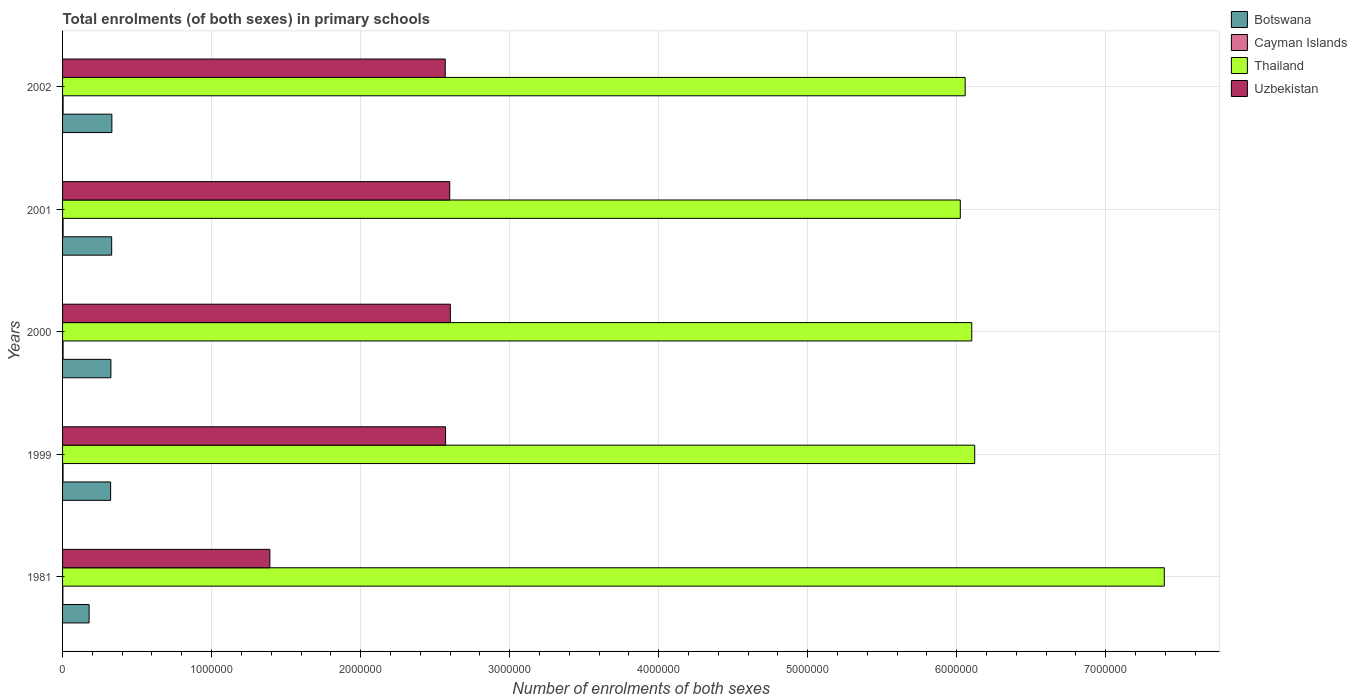How many different coloured bars are there?
Give a very brief answer. 4. How many groups of bars are there?
Make the answer very short. 5. Are the number of bars per tick equal to the number of legend labels?
Your answer should be very brief. Yes. Are the number of bars on each tick of the Y-axis equal?
Keep it short and to the point. Yes. How many bars are there on the 5th tick from the bottom?
Make the answer very short. 4. What is the number of enrolments in primary schools in Uzbekistan in 1999?
Your answer should be very brief. 2.57e+06. Across all years, what is the maximum number of enrolments in primary schools in Cayman Islands?
Your answer should be compact. 3579. Across all years, what is the minimum number of enrolments in primary schools in Uzbekistan?
Make the answer very short. 1.39e+06. What is the total number of enrolments in primary schools in Thailand in the graph?
Provide a short and direct response. 3.17e+07. What is the difference between the number of enrolments in primary schools in Thailand in 2000 and that in 2002?
Your answer should be very brief. 4.42e+04. What is the difference between the number of enrolments in primary schools in Cayman Islands in 1981 and the number of enrolments in primary schools in Thailand in 2002?
Make the answer very short. -6.05e+06. What is the average number of enrolments in primary schools in Uzbekistan per year?
Ensure brevity in your answer.  2.35e+06. In the year 2002, what is the difference between the number of enrolments in primary schools in Thailand and number of enrolments in primary schools in Botswana?
Ensure brevity in your answer.  5.73e+06. What is the ratio of the number of enrolments in primary schools in Uzbekistan in 1999 to that in 2002?
Give a very brief answer. 1. Is the number of enrolments in primary schools in Cayman Islands in 2001 less than that in 2002?
Keep it short and to the point. Yes. What is the difference between the highest and the second highest number of enrolments in primary schools in Thailand?
Provide a succinct answer. 1.27e+06. What is the difference between the highest and the lowest number of enrolments in primary schools in Cayman Islands?
Give a very brief answer. 1456. What does the 2nd bar from the top in 1981 represents?
Your answer should be very brief. Thailand. What does the 3rd bar from the bottom in 2000 represents?
Offer a very short reply. Thailand. How many bars are there?
Your answer should be very brief. 20. What is the difference between two consecutive major ticks on the X-axis?
Provide a succinct answer. 1.00e+06. Does the graph contain any zero values?
Make the answer very short. No. Does the graph contain grids?
Ensure brevity in your answer.  Yes. How many legend labels are there?
Offer a very short reply. 4. What is the title of the graph?
Provide a short and direct response. Total enrolments (of both sexes) in primary schools. What is the label or title of the X-axis?
Your answer should be very brief. Number of enrolments of both sexes. What is the Number of enrolments of both sexes of Botswana in 1981?
Your answer should be compact. 1.78e+05. What is the Number of enrolments of both sexes in Cayman Islands in 1981?
Provide a succinct answer. 2123. What is the Number of enrolments of both sexes in Thailand in 1981?
Make the answer very short. 7.39e+06. What is the Number of enrolments of both sexes of Uzbekistan in 1981?
Your response must be concise. 1.39e+06. What is the Number of enrolments of both sexes in Botswana in 1999?
Provide a succinct answer. 3.22e+05. What is the Number of enrolments of both sexes of Cayman Islands in 1999?
Offer a very short reply. 3231. What is the Number of enrolments of both sexes in Thailand in 1999?
Offer a terse response. 6.12e+06. What is the Number of enrolments of both sexes of Uzbekistan in 1999?
Provide a short and direct response. 2.57e+06. What is the Number of enrolments of both sexes of Botswana in 2000?
Your response must be concise. 3.24e+05. What is the Number of enrolments of both sexes of Cayman Islands in 2000?
Your answer should be very brief. 3435. What is the Number of enrolments of both sexes of Thailand in 2000?
Make the answer very short. 6.10e+06. What is the Number of enrolments of both sexes of Uzbekistan in 2000?
Give a very brief answer. 2.60e+06. What is the Number of enrolments of both sexes of Botswana in 2001?
Your answer should be compact. 3.29e+05. What is the Number of enrolments of both sexes of Cayman Islands in 2001?
Provide a short and direct response. 3549. What is the Number of enrolments of both sexes in Thailand in 2001?
Provide a short and direct response. 6.02e+06. What is the Number of enrolments of both sexes of Uzbekistan in 2001?
Offer a terse response. 2.60e+06. What is the Number of enrolments of both sexes of Botswana in 2002?
Provide a succinct answer. 3.31e+05. What is the Number of enrolments of both sexes of Cayman Islands in 2002?
Offer a very short reply. 3579. What is the Number of enrolments of both sexes in Thailand in 2002?
Ensure brevity in your answer.  6.06e+06. What is the Number of enrolments of both sexes in Uzbekistan in 2002?
Provide a succinct answer. 2.57e+06. Across all years, what is the maximum Number of enrolments of both sexes of Botswana?
Provide a short and direct response. 3.31e+05. Across all years, what is the maximum Number of enrolments of both sexes of Cayman Islands?
Keep it short and to the point. 3579. Across all years, what is the maximum Number of enrolments of both sexes in Thailand?
Your answer should be very brief. 7.39e+06. Across all years, what is the maximum Number of enrolments of both sexes in Uzbekistan?
Your answer should be compact. 2.60e+06. Across all years, what is the minimum Number of enrolments of both sexes in Botswana?
Keep it short and to the point. 1.78e+05. Across all years, what is the minimum Number of enrolments of both sexes in Cayman Islands?
Make the answer very short. 2123. Across all years, what is the minimum Number of enrolments of both sexes of Thailand?
Your response must be concise. 6.02e+06. Across all years, what is the minimum Number of enrolments of both sexes of Uzbekistan?
Your answer should be very brief. 1.39e+06. What is the total Number of enrolments of both sexes of Botswana in the graph?
Offer a very short reply. 1.49e+06. What is the total Number of enrolments of both sexes of Cayman Islands in the graph?
Give a very brief answer. 1.59e+04. What is the total Number of enrolments of both sexes in Thailand in the graph?
Offer a terse response. 3.17e+07. What is the total Number of enrolments of both sexes of Uzbekistan in the graph?
Ensure brevity in your answer.  1.17e+07. What is the difference between the Number of enrolments of both sexes in Botswana in 1981 and that in 1999?
Your response must be concise. -1.44e+05. What is the difference between the Number of enrolments of both sexes in Cayman Islands in 1981 and that in 1999?
Offer a very short reply. -1108. What is the difference between the Number of enrolments of both sexes of Thailand in 1981 and that in 1999?
Make the answer very short. 1.27e+06. What is the difference between the Number of enrolments of both sexes of Uzbekistan in 1981 and that in 1999?
Provide a succinct answer. -1.18e+06. What is the difference between the Number of enrolments of both sexes in Botswana in 1981 and that in 2000?
Your answer should be very brief. -1.46e+05. What is the difference between the Number of enrolments of both sexes of Cayman Islands in 1981 and that in 2000?
Provide a succinct answer. -1312. What is the difference between the Number of enrolments of both sexes in Thailand in 1981 and that in 2000?
Offer a terse response. 1.29e+06. What is the difference between the Number of enrolments of both sexes of Uzbekistan in 1981 and that in 2000?
Provide a succinct answer. -1.21e+06. What is the difference between the Number of enrolments of both sexes in Botswana in 1981 and that in 2001?
Your answer should be very brief. -1.51e+05. What is the difference between the Number of enrolments of both sexes of Cayman Islands in 1981 and that in 2001?
Offer a very short reply. -1426. What is the difference between the Number of enrolments of both sexes in Thailand in 1981 and that in 2001?
Offer a terse response. 1.37e+06. What is the difference between the Number of enrolments of both sexes in Uzbekistan in 1981 and that in 2001?
Offer a terse response. -1.21e+06. What is the difference between the Number of enrolments of both sexes in Botswana in 1981 and that in 2002?
Make the answer very short. -1.53e+05. What is the difference between the Number of enrolments of both sexes in Cayman Islands in 1981 and that in 2002?
Your answer should be very brief. -1456. What is the difference between the Number of enrolments of both sexes of Thailand in 1981 and that in 2002?
Give a very brief answer. 1.34e+06. What is the difference between the Number of enrolments of both sexes in Uzbekistan in 1981 and that in 2002?
Ensure brevity in your answer.  -1.18e+06. What is the difference between the Number of enrolments of both sexes of Botswana in 1999 and that in 2000?
Offer a very short reply. -1808. What is the difference between the Number of enrolments of both sexes in Cayman Islands in 1999 and that in 2000?
Your response must be concise. -204. What is the difference between the Number of enrolments of both sexes of Thailand in 1999 and that in 2000?
Keep it short and to the point. 1.98e+04. What is the difference between the Number of enrolments of both sexes of Uzbekistan in 1999 and that in 2000?
Keep it short and to the point. -3.21e+04. What is the difference between the Number of enrolments of both sexes of Botswana in 1999 and that in 2001?
Make the answer very short. -6976. What is the difference between the Number of enrolments of both sexes in Cayman Islands in 1999 and that in 2001?
Give a very brief answer. -318. What is the difference between the Number of enrolments of both sexes of Thailand in 1999 and that in 2001?
Provide a succinct answer. 9.67e+04. What is the difference between the Number of enrolments of both sexes in Uzbekistan in 1999 and that in 2001?
Keep it short and to the point. -2.80e+04. What is the difference between the Number of enrolments of both sexes in Botswana in 1999 and that in 2002?
Ensure brevity in your answer.  -8360. What is the difference between the Number of enrolments of both sexes of Cayman Islands in 1999 and that in 2002?
Ensure brevity in your answer.  -348. What is the difference between the Number of enrolments of both sexes of Thailand in 1999 and that in 2002?
Provide a short and direct response. 6.40e+04. What is the difference between the Number of enrolments of both sexes of Uzbekistan in 1999 and that in 2002?
Your answer should be compact. 2167. What is the difference between the Number of enrolments of both sexes of Botswana in 2000 and that in 2001?
Your answer should be very brief. -5168. What is the difference between the Number of enrolments of both sexes of Cayman Islands in 2000 and that in 2001?
Keep it short and to the point. -114. What is the difference between the Number of enrolments of both sexes in Thailand in 2000 and that in 2001?
Offer a terse response. 7.69e+04. What is the difference between the Number of enrolments of both sexes in Uzbekistan in 2000 and that in 2001?
Ensure brevity in your answer.  4067. What is the difference between the Number of enrolments of both sexes in Botswana in 2000 and that in 2002?
Ensure brevity in your answer.  -6552. What is the difference between the Number of enrolments of both sexes of Cayman Islands in 2000 and that in 2002?
Your answer should be very brief. -144. What is the difference between the Number of enrolments of both sexes in Thailand in 2000 and that in 2002?
Provide a succinct answer. 4.42e+04. What is the difference between the Number of enrolments of both sexes in Uzbekistan in 2000 and that in 2002?
Give a very brief answer. 3.43e+04. What is the difference between the Number of enrolments of both sexes in Botswana in 2001 and that in 2002?
Give a very brief answer. -1384. What is the difference between the Number of enrolments of both sexes of Cayman Islands in 2001 and that in 2002?
Your answer should be very brief. -30. What is the difference between the Number of enrolments of both sexes in Thailand in 2001 and that in 2002?
Your answer should be very brief. -3.27e+04. What is the difference between the Number of enrolments of both sexes in Uzbekistan in 2001 and that in 2002?
Your response must be concise. 3.02e+04. What is the difference between the Number of enrolments of both sexes of Botswana in 1981 and the Number of enrolments of both sexes of Cayman Islands in 1999?
Provide a short and direct response. 1.75e+05. What is the difference between the Number of enrolments of both sexes of Botswana in 1981 and the Number of enrolments of both sexes of Thailand in 1999?
Give a very brief answer. -5.94e+06. What is the difference between the Number of enrolments of both sexes of Botswana in 1981 and the Number of enrolments of both sexes of Uzbekistan in 1999?
Ensure brevity in your answer.  -2.39e+06. What is the difference between the Number of enrolments of both sexes of Cayman Islands in 1981 and the Number of enrolments of both sexes of Thailand in 1999?
Offer a terse response. -6.12e+06. What is the difference between the Number of enrolments of both sexes in Cayman Islands in 1981 and the Number of enrolments of both sexes in Uzbekistan in 1999?
Offer a very short reply. -2.57e+06. What is the difference between the Number of enrolments of both sexes in Thailand in 1981 and the Number of enrolments of both sexes in Uzbekistan in 1999?
Make the answer very short. 4.82e+06. What is the difference between the Number of enrolments of both sexes of Botswana in 1981 and the Number of enrolments of both sexes of Cayman Islands in 2000?
Keep it short and to the point. 1.75e+05. What is the difference between the Number of enrolments of both sexes in Botswana in 1981 and the Number of enrolments of both sexes in Thailand in 2000?
Your response must be concise. -5.92e+06. What is the difference between the Number of enrolments of both sexes in Botswana in 1981 and the Number of enrolments of both sexes in Uzbekistan in 2000?
Provide a short and direct response. -2.42e+06. What is the difference between the Number of enrolments of both sexes in Cayman Islands in 1981 and the Number of enrolments of both sexes in Thailand in 2000?
Provide a succinct answer. -6.10e+06. What is the difference between the Number of enrolments of both sexes in Cayman Islands in 1981 and the Number of enrolments of both sexes in Uzbekistan in 2000?
Keep it short and to the point. -2.60e+06. What is the difference between the Number of enrolments of both sexes of Thailand in 1981 and the Number of enrolments of both sexes of Uzbekistan in 2000?
Ensure brevity in your answer.  4.79e+06. What is the difference between the Number of enrolments of both sexes in Botswana in 1981 and the Number of enrolments of both sexes in Cayman Islands in 2001?
Make the answer very short. 1.75e+05. What is the difference between the Number of enrolments of both sexes of Botswana in 1981 and the Number of enrolments of both sexes of Thailand in 2001?
Provide a succinct answer. -5.85e+06. What is the difference between the Number of enrolments of both sexes in Botswana in 1981 and the Number of enrolments of both sexes in Uzbekistan in 2001?
Your answer should be very brief. -2.42e+06. What is the difference between the Number of enrolments of both sexes in Cayman Islands in 1981 and the Number of enrolments of both sexes in Thailand in 2001?
Your response must be concise. -6.02e+06. What is the difference between the Number of enrolments of both sexes in Cayman Islands in 1981 and the Number of enrolments of both sexes in Uzbekistan in 2001?
Make the answer very short. -2.60e+06. What is the difference between the Number of enrolments of both sexes in Thailand in 1981 and the Number of enrolments of both sexes in Uzbekistan in 2001?
Keep it short and to the point. 4.79e+06. What is the difference between the Number of enrolments of both sexes of Botswana in 1981 and the Number of enrolments of both sexes of Cayman Islands in 2002?
Ensure brevity in your answer.  1.75e+05. What is the difference between the Number of enrolments of both sexes in Botswana in 1981 and the Number of enrolments of both sexes in Thailand in 2002?
Make the answer very short. -5.88e+06. What is the difference between the Number of enrolments of both sexes of Botswana in 1981 and the Number of enrolments of both sexes of Uzbekistan in 2002?
Ensure brevity in your answer.  -2.39e+06. What is the difference between the Number of enrolments of both sexes of Cayman Islands in 1981 and the Number of enrolments of both sexes of Thailand in 2002?
Provide a succinct answer. -6.05e+06. What is the difference between the Number of enrolments of both sexes in Cayman Islands in 1981 and the Number of enrolments of both sexes in Uzbekistan in 2002?
Your answer should be very brief. -2.57e+06. What is the difference between the Number of enrolments of both sexes in Thailand in 1981 and the Number of enrolments of both sexes in Uzbekistan in 2002?
Provide a short and direct response. 4.82e+06. What is the difference between the Number of enrolments of both sexes of Botswana in 1999 and the Number of enrolments of both sexes of Cayman Islands in 2000?
Provide a short and direct response. 3.19e+05. What is the difference between the Number of enrolments of both sexes in Botswana in 1999 and the Number of enrolments of both sexes in Thailand in 2000?
Provide a short and direct response. -5.78e+06. What is the difference between the Number of enrolments of both sexes of Botswana in 1999 and the Number of enrolments of both sexes of Uzbekistan in 2000?
Provide a short and direct response. -2.28e+06. What is the difference between the Number of enrolments of both sexes in Cayman Islands in 1999 and the Number of enrolments of both sexes in Thailand in 2000?
Make the answer very short. -6.10e+06. What is the difference between the Number of enrolments of both sexes of Cayman Islands in 1999 and the Number of enrolments of both sexes of Uzbekistan in 2000?
Give a very brief answer. -2.60e+06. What is the difference between the Number of enrolments of both sexes in Thailand in 1999 and the Number of enrolments of both sexes in Uzbekistan in 2000?
Your response must be concise. 3.52e+06. What is the difference between the Number of enrolments of both sexes in Botswana in 1999 and the Number of enrolments of both sexes in Cayman Islands in 2001?
Your response must be concise. 3.19e+05. What is the difference between the Number of enrolments of both sexes in Botswana in 1999 and the Number of enrolments of both sexes in Thailand in 2001?
Offer a very short reply. -5.70e+06. What is the difference between the Number of enrolments of both sexes in Botswana in 1999 and the Number of enrolments of both sexes in Uzbekistan in 2001?
Give a very brief answer. -2.28e+06. What is the difference between the Number of enrolments of both sexes in Cayman Islands in 1999 and the Number of enrolments of both sexes in Thailand in 2001?
Make the answer very short. -6.02e+06. What is the difference between the Number of enrolments of both sexes in Cayman Islands in 1999 and the Number of enrolments of both sexes in Uzbekistan in 2001?
Give a very brief answer. -2.59e+06. What is the difference between the Number of enrolments of both sexes in Thailand in 1999 and the Number of enrolments of both sexes in Uzbekistan in 2001?
Give a very brief answer. 3.52e+06. What is the difference between the Number of enrolments of both sexes of Botswana in 1999 and the Number of enrolments of both sexes of Cayman Islands in 2002?
Provide a short and direct response. 3.19e+05. What is the difference between the Number of enrolments of both sexes of Botswana in 1999 and the Number of enrolments of both sexes of Thailand in 2002?
Keep it short and to the point. -5.73e+06. What is the difference between the Number of enrolments of both sexes of Botswana in 1999 and the Number of enrolments of both sexes of Uzbekistan in 2002?
Offer a terse response. -2.25e+06. What is the difference between the Number of enrolments of both sexes in Cayman Islands in 1999 and the Number of enrolments of both sexes in Thailand in 2002?
Provide a short and direct response. -6.05e+06. What is the difference between the Number of enrolments of both sexes in Cayman Islands in 1999 and the Number of enrolments of both sexes in Uzbekistan in 2002?
Offer a very short reply. -2.56e+06. What is the difference between the Number of enrolments of both sexes of Thailand in 1999 and the Number of enrolments of both sexes of Uzbekistan in 2002?
Provide a short and direct response. 3.55e+06. What is the difference between the Number of enrolments of both sexes in Botswana in 2000 and the Number of enrolments of both sexes in Cayman Islands in 2001?
Your answer should be very brief. 3.21e+05. What is the difference between the Number of enrolments of both sexes of Botswana in 2000 and the Number of enrolments of both sexes of Thailand in 2001?
Your answer should be compact. -5.70e+06. What is the difference between the Number of enrolments of both sexes in Botswana in 2000 and the Number of enrolments of both sexes in Uzbekistan in 2001?
Provide a short and direct response. -2.27e+06. What is the difference between the Number of enrolments of both sexes in Cayman Islands in 2000 and the Number of enrolments of both sexes in Thailand in 2001?
Make the answer very short. -6.02e+06. What is the difference between the Number of enrolments of both sexes in Cayman Islands in 2000 and the Number of enrolments of both sexes in Uzbekistan in 2001?
Keep it short and to the point. -2.59e+06. What is the difference between the Number of enrolments of both sexes in Thailand in 2000 and the Number of enrolments of both sexes in Uzbekistan in 2001?
Your answer should be very brief. 3.50e+06. What is the difference between the Number of enrolments of both sexes of Botswana in 2000 and the Number of enrolments of both sexes of Cayman Islands in 2002?
Your answer should be compact. 3.21e+05. What is the difference between the Number of enrolments of both sexes in Botswana in 2000 and the Number of enrolments of both sexes in Thailand in 2002?
Your answer should be compact. -5.73e+06. What is the difference between the Number of enrolments of both sexes in Botswana in 2000 and the Number of enrolments of both sexes in Uzbekistan in 2002?
Offer a very short reply. -2.24e+06. What is the difference between the Number of enrolments of both sexes of Cayman Islands in 2000 and the Number of enrolments of both sexes of Thailand in 2002?
Your response must be concise. -6.05e+06. What is the difference between the Number of enrolments of both sexes of Cayman Islands in 2000 and the Number of enrolments of both sexes of Uzbekistan in 2002?
Provide a succinct answer. -2.56e+06. What is the difference between the Number of enrolments of both sexes in Thailand in 2000 and the Number of enrolments of both sexes in Uzbekistan in 2002?
Make the answer very short. 3.53e+06. What is the difference between the Number of enrolments of both sexes in Botswana in 2001 and the Number of enrolments of both sexes in Cayman Islands in 2002?
Ensure brevity in your answer.  3.26e+05. What is the difference between the Number of enrolments of both sexes in Botswana in 2001 and the Number of enrolments of both sexes in Thailand in 2002?
Your answer should be very brief. -5.73e+06. What is the difference between the Number of enrolments of both sexes of Botswana in 2001 and the Number of enrolments of both sexes of Uzbekistan in 2002?
Ensure brevity in your answer.  -2.24e+06. What is the difference between the Number of enrolments of both sexes in Cayman Islands in 2001 and the Number of enrolments of both sexes in Thailand in 2002?
Give a very brief answer. -6.05e+06. What is the difference between the Number of enrolments of both sexes in Cayman Islands in 2001 and the Number of enrolments of both sexes in Uzbekistan in 2002?
Offer a terse response. -2.56e+06. What is the difference between the Number of enrolments of both sexes in Thailand in 2001 and the Number of enrolments of both sexes in Uzbekistan in 2002?
Make the answer very short. 3.46e+06. What is the average Number of enrolments of both sexes of Botswana per year?
Your answer should be very brief. 2.97e+05. What is the average Number of enrolments of both sexes in Cayman Islands per year?
Keep it short and to the point. 3183.4. What is the average Number of enrolments of both sexes of Thailand per year?
Keep it short and to the point. 6.34e+06. What is the average Number of enrolments of both sexes in Uzbekistan per year?
Keep it short and to the point. 2.35e+06. In the year 1981, what is the difference between the Number of enrolments of both sexes of Botswana and Number of enrolments of both sexes of Cayman Islands?
Provide a short and direct response. 1.76e+05. In the year 1981, what is the difference between the Number of enrolments of both sexes of Botswana and Number of enrolments of both sexes of Thailand?
Offer a very short reply. -7.21e+06. In the year 1981, what is the difference between the Number of enrolments of both sexes in Botswana and Number of enrolments of both sexes in Uzbekistan?
Your answer should be compact. -1.21e+06. In the year 1981, what is the difference between the Number of enrolments of both sexes in Cayman Islands and Number of enrolments of both sexes in Thailand?
Offer a very short reply. -7.39e+06. In the year 1981, what is the difference between the Number of enrolments of both sexes in Cayman Islands and Number of enrolments of both sexes in Uzbekistan?
Your answer should be compact. -1.39e+06. In the year 1981, what is the difference between the Number of enrolments of both sexes of Thailand and Number of enrolments of both sexes of Uzbekistan?
Your answer should be compact. 6.00e+06. In the year 1999, what is the difference between the Number of enrolments of both sexes of Botswana and Number of enrolments of both sexes of Cayman Islands?
Offer a terse response. 3.19e+05. In the year 1999, what is the difference between the Number of enrolments of both sexes in Botswana and Number of enrolments of both sexes in Thailand?
Provide a succinct answer. -5.80e+06. In the year 1999, what is the difference between the Number of enrolments of both sexes of Botswana and Number of enrolments of both sexes of Uzbekistan?
Ensure brevity in your answer.  -2.25e+06. In the year 1999, what is the difference between the Number of enrolments of both sexes in Cayman Islands and Number of enrolments of both sexes in Thailand?
Give a very brief answer. -6.12e+06. In the year 1999, what is the difference between the Number of enrolments of both sexes of Cayman Islands and Number of enrolments of both sexes of Uzbekistan?
Offer a very short reply. -2.57e+06. In the year 1999, what is the difference between the Number of enrolments of both sexes of Thailand and Number of enrolments of both sexes of Uzbekistan?
Provide a short and direct response. 3.55e+06. In the year 2000, what is the difference between the Number of enrolments of both sexes in Botswana and Number of enrolments of both sexes in Cayman Islands?
Provide a short and direct response. 3.21e+05. In the year 2000, what is the difference between the Number of enrolments of both sexes in Botswana and Number of enrolments of both sexes in Thailand?
Your answer should be compact. -5.78e+06. In the year 2000, what is the difference between the Number of enrolments of both sexes in Botswana and Number of enrolments of both sexes in Uzbekistan?
Make the answer very short. -2.28e+06. In the year 2000, what is the difference between the Number of enrolments of both sexes in Cayman Islands and Number of enrolments of both sexes in Thailand?
Offer a terse response. -6.10e+06. In the year 2000, what is the difference between the Number of enrolments of both sexes of Cayman Islands and Number of enrolments of both sexes of Uzbekistan?
Give a very brief answer. -2.60e+06. In the year 2000, what is the difference between the Number of enrolments of both sexes of Thailand and Number of enrolments of both sexes of Uzbekistan?
Make the answer very short. 3.50e+06. In the year 2001, what is the difference between the Number of enrolments of both sexes in Botswana and Number of enrolments of both sexes in Cayman Islands?
Your response must be concise. 3.26e+05. In the year 2001, what is the difference between the Number of enrolments of both sexes in Botswana and Number of enrolments of both sexes in Thailand?
Your answer should be compact. -5.69e+06. In the year 2001, what is the difference between the Number of enrolments of both sexes of Botswana and Number of enrolments of both sexes of Uzbekistan?
Give a very brief answer. -2.27e+06. In the year 2001, what is the difference between the Number of enrolments of both sexes in Cayman Islands and Number of enrolments of both sexes in Thailand?
Provide a short and direct response. -6.02e+06. In the year 2001, what is the difference between the Number of enrolments of both sexes in Cayman Islands and Number of enrolments of both sexes in Uzbekistan?
Your response must be concise. -2.59e+06. In the year 2001, what is the difference between the Number of enrolments of both sexes in Thailand and Number of enrolments of both sexes in Uzbekistan?
Ensure brevity in your answer.  3.43e+06. In the year 2002, what is the difference between the Number of enrolments of both sexes of Botswana and Number of enrolments of both sexes of Cayman Islands?
Offer a very short reply. 3.27e+05. In the year 2002, what is the difference between the Number of enrolments of both sexes of Botswana and Number of enrolments of both sexes of Thailand?
Ensure brevity in your answer.  -5.73e+06. In the year 2002, what is the difference between the Number of enrolments of both sexes of Botswana and Number of enrolments of both sexes of Uzbekistan?
Ensure brevity in your answer.  -2.24e+06. In the year 2002, what is the difference between the Number of enrolments of both sexes in Cayman Islands and Number of enrolments of both sexes in Thailand?
Offer a terse response. -6.05e+06. In the year 2002, what is the difference between the Number of enrolments of both sexes in Cayman Islands and Number of enrolments of both sexes in Uzbekistan?
Your response must be concise. -2.56e+06. In the year 2002, what is the difference between the Number of enrolments of both sexes of Thailand and Number of enrolments of both sexes of Uzbekistan?
Give a very brief answer. 3.49e+06. What is the ratio of the Number of enrolments of both sexes in Botswana in 1981 to that in 1999?
Give a very brief answer. 0.55. What is the ratio of the Number of enrolments of both sexes in Cayman Islands in 1981 to that in 1999?
Your answer should be very brief. 0.66. What is the ratio of the Number of enrolments of both sexes of Thailand in 1981 to that in 1999?
Provide a short and direct response. 1.21. What is the ratio of the Number of enrolments of both sexes in Uzbekistan in 1981 to that in 1999?
Provide a short and direct response. 0.54. What is the ratio of the Number of enrolments of both sexes of Botswana in 1981 to that in 2000?
Provide a succinct answer. 0.55. What is the ratio of the Number of enrolments of both sexes of Cayman Islands in 1981 to that in 2000?
Offer a very short reply. 0.62. What is the ratio of the Number of enrolments of both sexes of Thailand in 1981 to that in 2000?
Offer a very short reply. 1.21. What is the ratio of the Number of enrolments of both sexes in Uzbekistan in 1981 to that in 2000?
Your answer should be very brief. 0.53. What is the ratio of the Number of enrolments of both sexes in Botswana in 1981 to that in 2001?
Make the answer very short. 0.54. What is the ratio of the Number of enrolments of both sexes in Cayman Islands in 1981 to that in 2001?
Your answer should be very brief. 0.6. What is the ratio of the Number of enrolments of both sexes in Thailand in 1981 to that in 2001?
Your answer should be compact. 1.23. What is the ratio of the Number of enrolments of both sexes of Uzbekistan in 1981 to that in 2001?
Offer a very short reply. 0.54. What is the ratio of the Number of enrolments of both sexes of Botswana in 1981 to that in 2002?
Provide a succinct answer. 0.54. What is the ratio of the Number of enrolments of both sexes in Cayman Islands in 1981 to that in 2002?
Your response must be concise. 0.59. What is the ratio of the Number of enrolments of both sexes of Thailand in 1981 to that in 2002?
Make the answer very short. 1.22. What is the ratio of the Number of enrolments of both sexes of Uzbekistan in 1981 to that in 2002?
Your response must be concise. 0.54. What is the ratio of the Number of enrolments of both sexes in Botswana in 1999 to that in 2000?
Your answer should be compact. 0.99. What is the ratio of the Number of enrolments of both sexes of Cayman Islands in 1999 to that in 2000?
Ensure brevity in your answer.  0.94. What is the ratio of the Number of enrolments of both sexes of Botswana in 1999 to that in 2001?
Your response must be concise. 0.98. What is the ratio of the Number of enrolments of both sexes of Cayman Islands in 1999 to that in 2001?
Offer a terse response. 0.91. What is the ratio of the Number of enrolments of both sexes of Thailand in 1999 to that in 2001?
Your response must be concise. 1.02. What is the ratio of the Number of enrolments of both sexes in Botswana in 1999 to that in 2002?
Your answer should be compact. 0.97. What is the ratio of the Number of enrolments of both sexes of Cayman Islands in 1999 to that in 2002?
Your answer should be very brief. 0.9. What is the ratio of the Number of enrolments of both sexes in Thailand in 1999 to that in 2002?
Provide a short and direct response. 1.01. What is the ratio of the Number of enrolments of both sexes of Uzbekistan in 1999 to that in 2002?
Provide a short and direct response. 1. What is the ratio of the Number of enrolments of both sexes in Botswana in 2000 to that in 2001?
Your answer should be compact. 0.98. What is the ratio of the Number of enrolments of both sexes of Cayman Islands in 2000 to that in 2001?
Keep it short and to the point. 0.97. What is the ratio of the Number of enrolments of both sexes in Thailand in 2000 to that in 2001?
Make the answer very short. 1.01. What is the ratio of the Number of enrolments of both sexes in Uzbekistan in 2000 to that in 2001?
Offer a terse response. 1. What is the ratio of the Number of enrolments of both sexes in Botswana in 2000 to that in 2002?
Make the answer very short. 0.98. What is the ratio of the Number of enrolments of both sexes of Cayman Islands in 2000 to that in 2002?
Your answer should be very brief. 0.96. What is the ratio of the Number of enrolments of both sexes in Thailand in 2000 to that in 2002?
Keep it short and to the point. 1.01. What is the ratio of the Number of enrolments of both sexes of Uzbekistan in 2000 to that in 2002?
Offer a very short reply. 1.01. What is the ratio of the Number of enrolments of both sexes of Cayman Islands in 2001 to that in 2002?
Offer a terse response. 0.99. What is the ratio of the Number of enrolments of both sexes of Thailand in 2001 to that in 2002?
Make the answer very short. 0.99. What is the ratio of the Number of enrolments of both sexes of Uzbekistan in 2001 to that in 2002?
Make the answer very short. 1.01. What is the difference between the highest and the second highest Number of enrolments of both sexes in Botswana?
Keep it short and to the point. 1384. What is the difference between the highest and the second highest Number of enrolments of both sexes in Thailand?
Offer a terse response. 1.27e+06. What is the difference between the highest and the second highest Number of enrolments of both sexes of Uzbekistan?
Provide a short and direct response. 4067. What is the difference between the highest and the lowest Number of enrolments of both sexes in Botswana?
Your answer should be very brief. 1.53e+05. What is the difference between the highest and the lowest Number of enrolments of both sexes of Cayman Islands?
Offer a very short reply. 1456. What is the difference between the highest and the lowest Number of enrolments of both sexes of Thailand?
Your response must be concise. 1.37e+06. What is the difference between the highest and the lowest Number of enrolments of both sexes of Uzbekistan?
Your answer should be compact. 1.21e+06. 